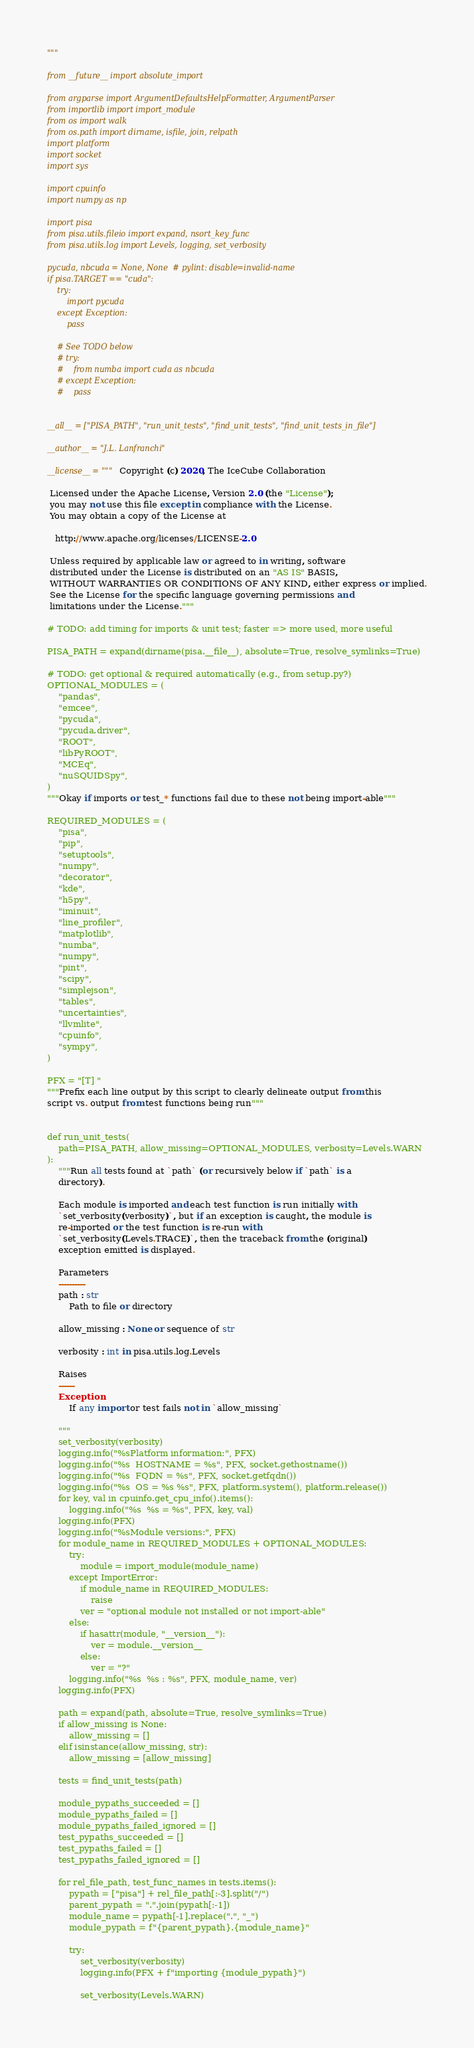<code> <loc_0><loc_0><loc_500><loc_500><_Python_>"""

from __future__ import absolute_import

from argparse import ArgumentDefaultsHelpFormatter, ArgumentParser
from importlib import import_module
from os import walk
from os.path import dirname, isfile, join, relpath
import platform
import socket
import sys

import cpuinfo
import numpy as np

import pisa
from pisa.utils.fileio import expand, nsort_key_func
from pisa.utils.log import Levels, logging, set_verbosity

pycuda, nbcuda = None, None  # pylint: disable=invalid-name
if pisa.TARGET == "cuda":
    try:
        import pycuda
    except Exception:
        pass

    # See TODO below
    # try:
    #    from numba import cuda as nbcuda
    # except Exception:
    #    pass


__all__ = ["PISA_PATH", "run_unit_tests", "find_unit_tests", "find_unit_tests_in_file"]

__author__ = "J.L. Lanfranchi"

__license__ = """Copyright (c) 2020, The IceCube Collaboration

 Licensed under the Apache License, Version 2.0 (the "License");
 you may not use this file except in compliance with the License.
 You may obtain a copy of the License at

   http://www.apache.org/licenses/LICENSE-2.0

 Unless required by applicable law or agreed to in writing, software
 distributed under the License is distributed on an "AS IS" BASIS,
 WITHOUT WARRANTIES OR CONDITIONS OF ANY KIND, either express or implied.
 See the License for the specific language governing permissions and
 limitations under the License."""

# TODO: add timing for imports & unit test; faster => more used, more useful

PISA_PATH = expand(dirname(pisa.__file__), absolute=True, resolve_symlinks=True)

# TODO: get optional & required automatically (e.g., from setup.py?)
OPTIONAL_MODULES = (
    "pandas",
    "emcee",
    "pycuda",
    "pycuda.driver",
    "ROOT",
    "libPyROOT",
    "MCEq",
    "nuSQUIDSpy",
)
"""Okay if imports or test_* functions fail due to these not being import-able"""

REQUIRED_MODULES = (
    "pisa",
    "pip",
    "setuptools",
    "numpy",
    "decorator",
    "kde",
    "h5py",
    "iminuit",
    "line_profiler",
    "matplotlib",
    "numba",
    "numpy",
    "pint",
    "scipy",
    "simplejson",
    "tables",
    "uncertainties",
    "llvmlite",
    "cpuinfo",
    "sympy",
)

PFX = "[T] "
"""Prefix each line output by this script to clearly delineate output from this
script vs. output from test functions being run"""


def run_unit_tests(
    path=PISA_PATH, allow_missing=OPTIONAL_MODULES, verbosity=Levels.WARN
):
    """Run all tests found at `path` (or recursively below if `path` is a
    directory).

    Each module is imported and each test function is run initially with
    `set_verbosity(verbosity)`, but if an exception is caught, the module is
    re-imported or the test function is re-run with
    `set_verbosity(Levels.TRACE)`, then the traceback from the (original)
    exception emitted is displayed.

    Parameters
    ----------
    path : str
        Path to file or directory

    allow_missing : None or sequence of str

    verbosity : int in pisa.utils.log.Levels

    Raises
    ------
    Exception
        If any import or test fails not in `allow_missing`

    """
    set_verbosity(verbosity)
    logging.info("%sPlatform information:", PFX)
    logging.info("%s  HOSTNAME = %s", PFX, socket.gethostname())
    logging.info("%s  FQDN = %s", PFX, socket.getfqdn())
    logging.info("%s  OS = %s %s", PFX, platform.system(), platform.release())
    for key, val in cpuinfo.get_cpu_info().items():
        logging.info("%s  %s = %s", PFX, key, val)
    logging.info(PFX)
    logging.info("%sModule versions:", PFX)
    for module_name in REQUIRED_MODULES + OPTIONAL_MODULES:
        try:
            module = import_module(module_name)
        except ImportError:
            if module_name in REQUIRED_MODULES:
                raise
            ver = "optional module not installed or not import-able"
        else:
            if hasattr(module, "__version__"):
                ver = module.__version__
            else:
                ver = "?"
        logging.info("%s  %s : %s", PFX, module_name, ver)
    logging.info(PFX)

    path = expand(path, absolute=True, resolve_symlinks=True)
    if allow_missing is None:
        allow_missing = []
    elif isinstance(allow_missing, str):
        allow_missing = [allow_missing]

    tests = find_unit_tests(path)

    module_pypaths_succeeded = []
    module_pypaths_failed = []
    module_pypaths_failed_ignored = []
    test_pypaths_succeeded = []
    test_pypaths_failed = []
    test_pypaths_failed_ignored = []

    for rel_file_path, test_func_names in tests.items():
        pypath = ["pisa"] + rel_file_path[:-3].split("/")
        parent_pypath = ".".join(pypath[:-1])
        module_name = pypath[-1].replace(".", "_")
        module_pypath = f"{parent_pypath}.{module_name}"

        try:
            set_verbosity(verbosity)
            logging.info(PFX + f"importing {module_pypath}")

            set_verbosity(Levels.WARN)</code> 